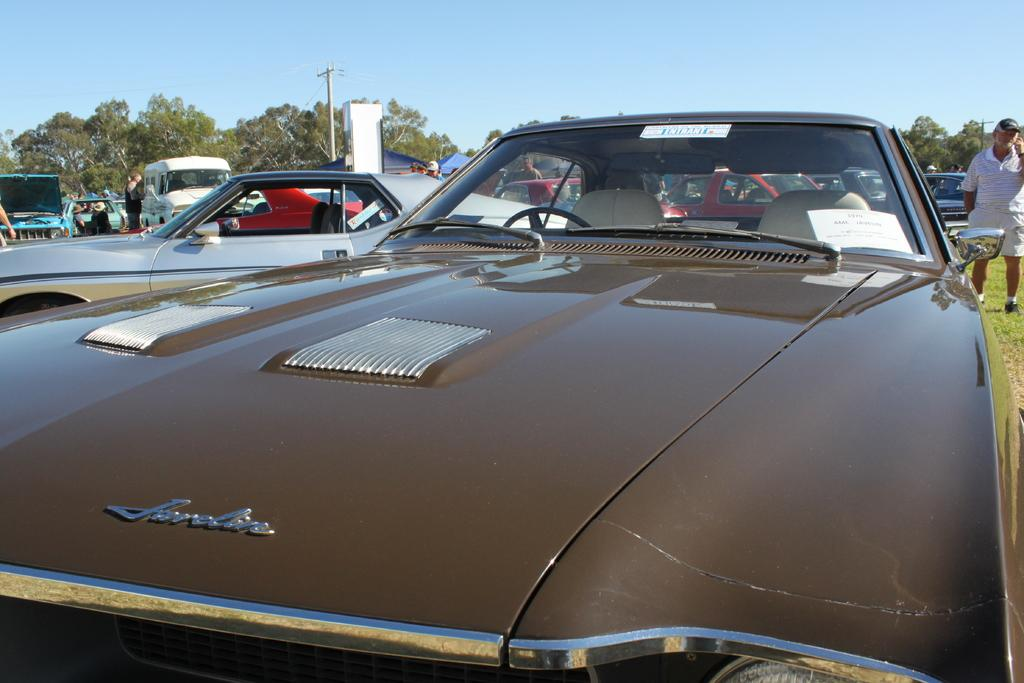What type of car is in the foreground of the image? There is a brown color car in the foreground of the image. Who or what is on the right side of the image? There is a man standing on the right side of the image. What can be seen in the background of the image? There are vehicles, poles, trees, and the sky visible in the background of the image. Reasoning: Let' Let's think step by step in order to produce the conversation. We start by identifying the main subject in the image, which is the brown color car in the foreground. Then, we expand the conversation to include the man standing on the right side of the image. Finally, we describe the background of the image, which includes various objects and the sky. Each question is designed to elicit a specific detail about the image that is known from the provided facts. Absurd Question/Answer: How many cushions are visible in the image? There are no cushions present in the image. What is the man doing with his hand in the image? There is no indication of the man's hand or any action involving it in the image. 